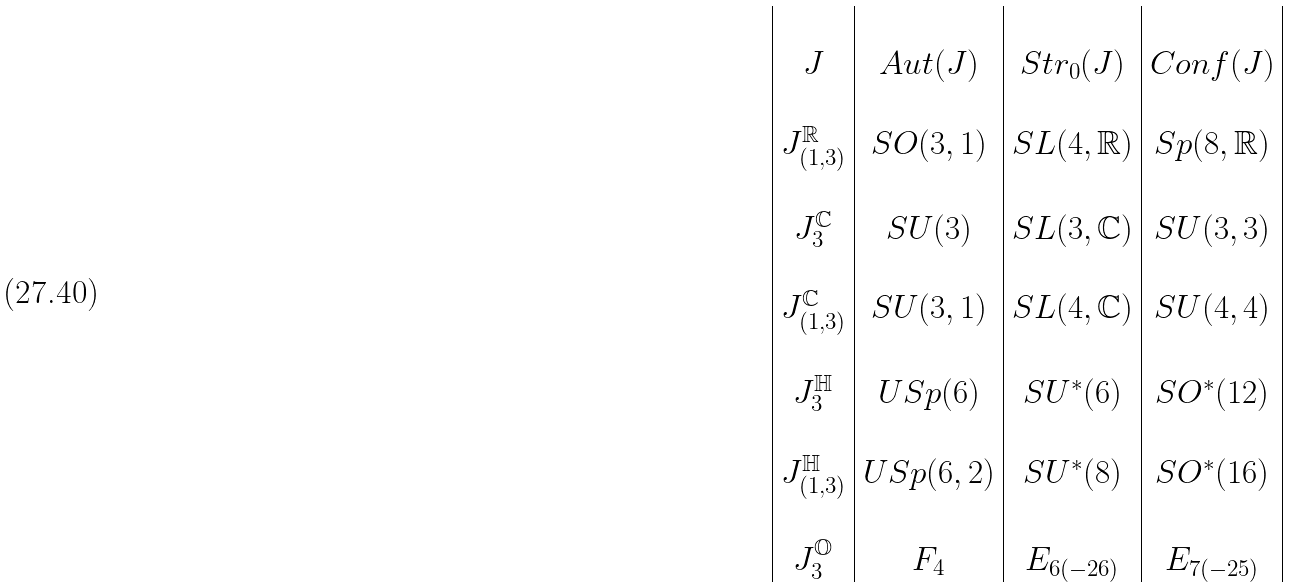Convert formula to latex. <formula><loc_0><loc_0><loc_500><loc_500>\begin{array} { | c | c | c | c | } & & & \\ J & A u t ( J ) & S t r _ { 0 } ( J ) & C o n f ( J ) \\ & & & \\ J _ { ( 1 , 3 ) } ^ { \mathbb { R } } & S O ( 3 , 1 ) & S L ( 4 , \mathbb { R } ) & S p ( 8 , \mathbb { R } ) \\ & & & \\ J _ { 3 } ^ { \mathbb { C } } & S U ( 3 ) & S L ( 3 , \mathbb { C } ) & S U ( 3 , 3 ) \\ & & & \\ J _ { ( 1 , 3 ) } ^ { \mathbb { C } } & S U ( 3 , 1 ) & S L ( 4 , \mathbb { C } ) & S U ( 4 , 4 ) \\ & & & \\ J _ { 3 } ^ { \mathbb { H } } & U S p ( 6 ) & S U ^ { * } ( 6 ) & S O ^ { * } ( 1 2 ) \\ & & & \\ J _ { ( 1 , 3 ) } ^ { \mathbb { H } } & U S p ( 6 , 2 ) & S U ^ { * } ( 8 ) & S O ^ { * } ( 1 6 ) \\ & & & \\ J _ { 3 } ^ { \mathbb { O } } & F _ { 4 } & E _ { 6 ( - 2 6 ) } & E _ { 7 ( - 2 5 ) } \\ \end{array}</formula> 